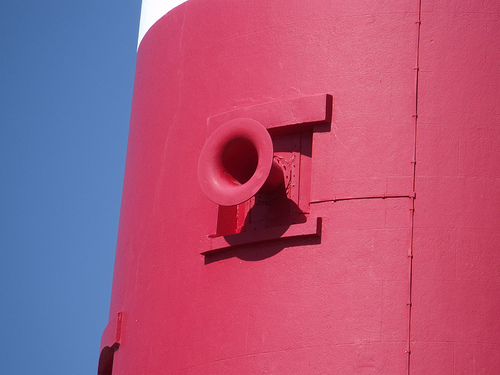<image>
Can you confirm if the metal is behind the tube? Yes. From this viewpoint, the metal is positioned behind the tube, with the tube partially or fully occluding the metal. 